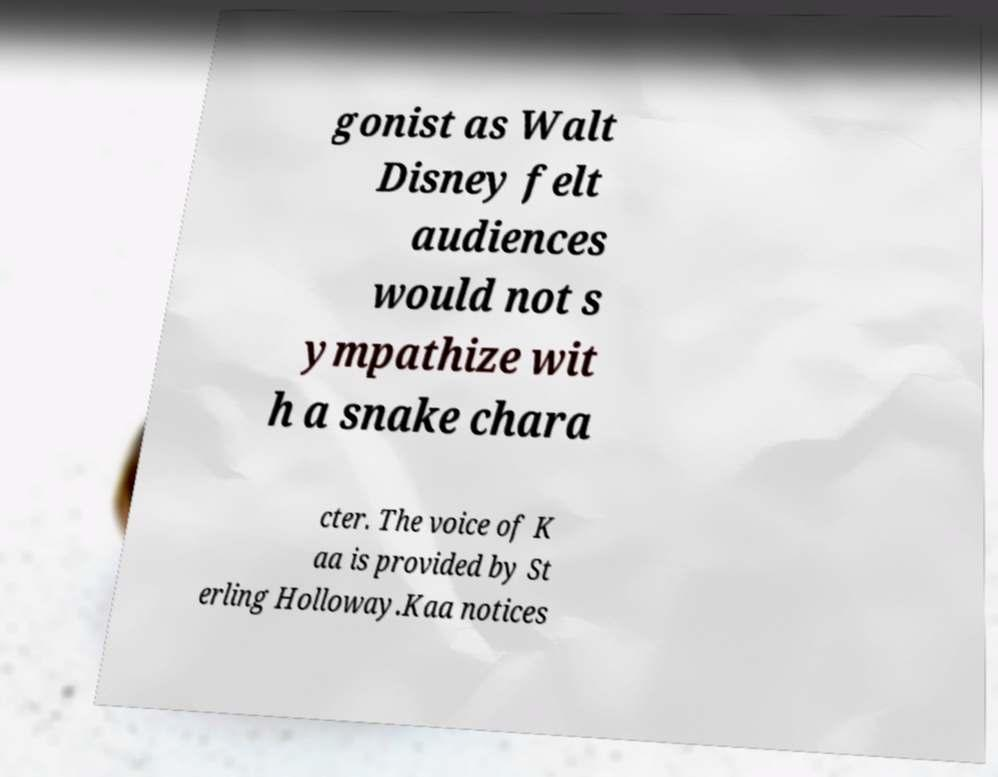For documentation purposes, I need the text within this image transcribed. Could you provide that? gonist as Walt Disney felt audiences would not s ympathize wit h a snake chara cter. The voice of K aa is provided by St erling Holloway.Kaa notices 